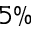<formula> <loc_0><loc_0><loc_500><loc_500>5 \%</formula> 